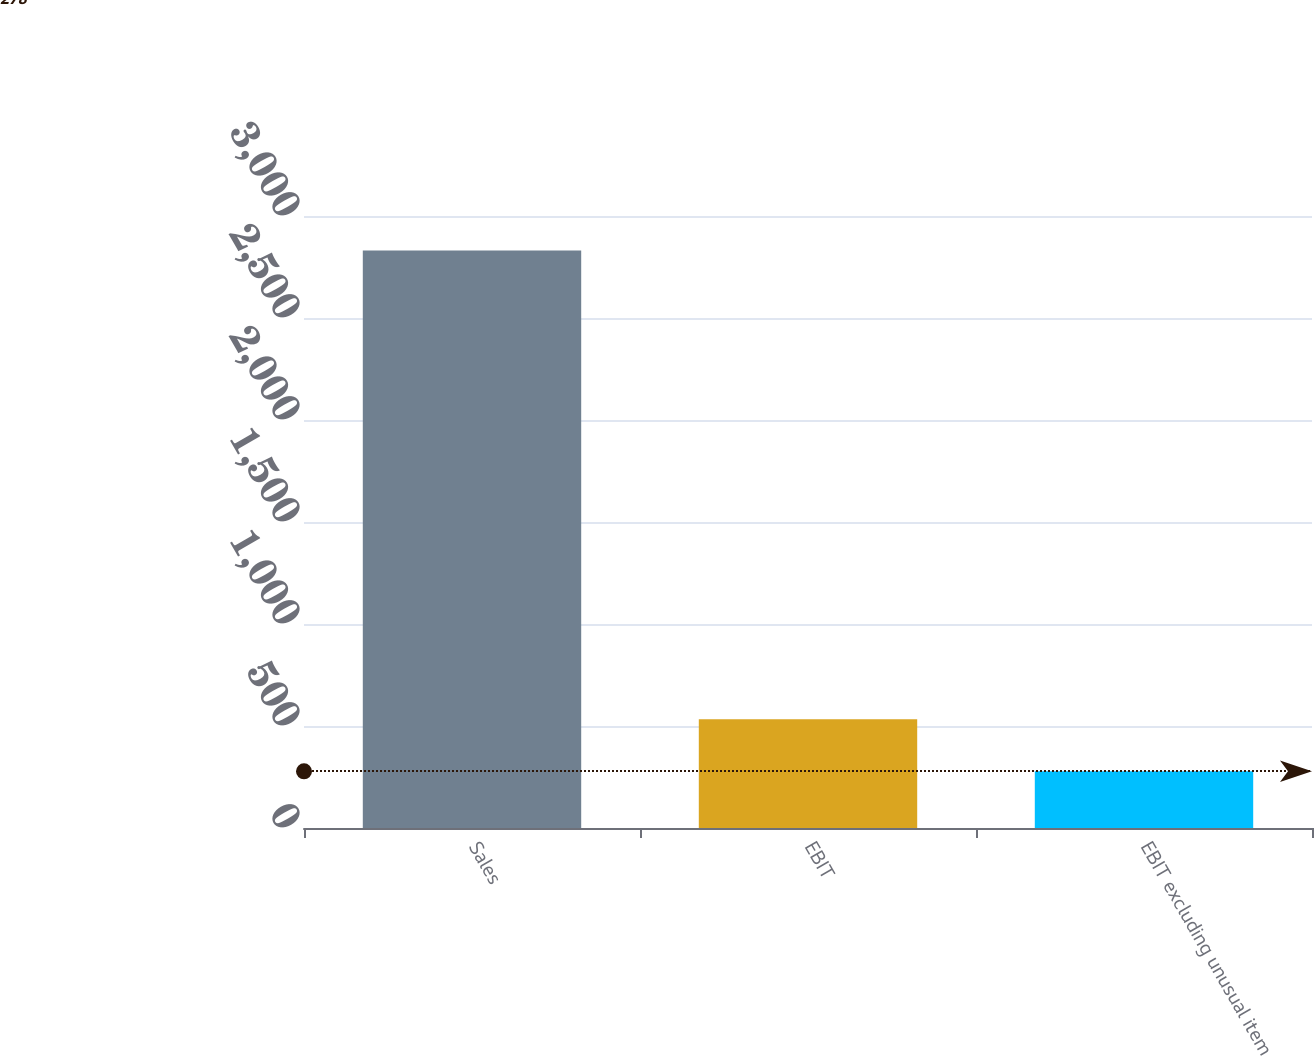<chart> <loc_0><loc_0><loc_500><loc_500><bar_chart><fcel>Sales<fcel>EBIT<fcel>EBIT excluding unusual item<nl><fcel>2831<fcel>533.3<fcel>278<nl></chart> 